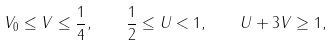<formula> <loc_0><loc_0><loc_500><loc_500>V _ { 0 } \leq V \leq { \frac { 1 } { 4 } } , \quad { \frac { 1 } { 2 } } \leq U < 1 , \quad U + 3 V \geq 1 ,</formula> 